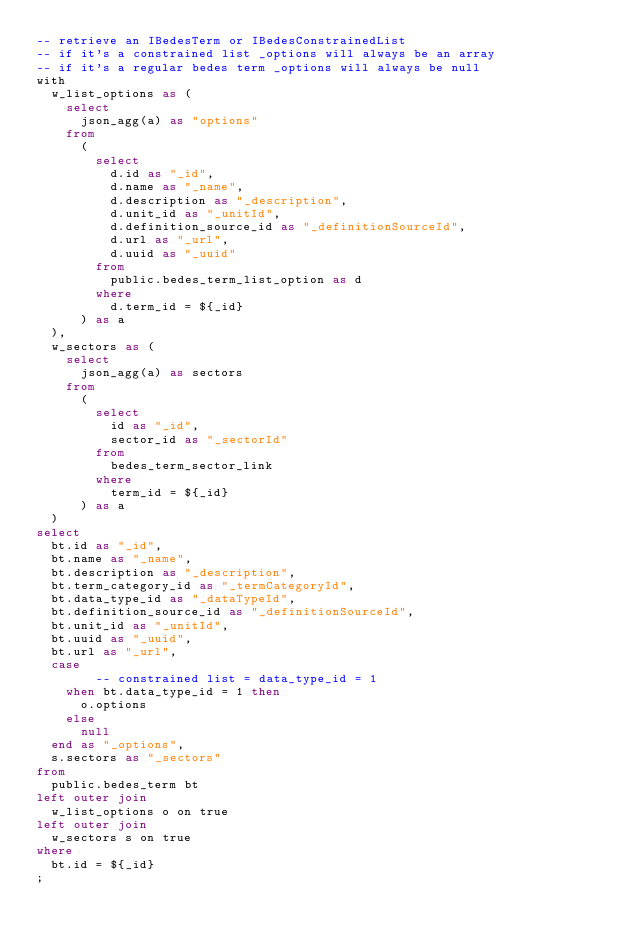Convert code to text. <code><loc_0><loc_0><loc_500><loc_500><_SQL_>-- retrieve an IBedesTerm or IBedesConstrainedList
-- if it's a constrained list _options will always be an array
-- if it's a regular bedes term _options will always be null
with
	w_list_options as (
		select
			json_agg(a) as "options"
		from
			(
				select
					d.id as "_id",
					d.name as "_name",
					d.description as "_description",
					d.unit_id as "_unitId",
					d.definition_source_id as "_definitionSourceId",
					d.url as "_url",
					d.uuid as "_uuid"
				from
					public.bedes_term_list_option as d
				where
					d.term_id = ${_id}
			) as a
	),
	w_sectors as (
		select
			json_agg(a) as sectors
		from
			(
				select
					id as "_id",
					sector_id as "_sectorId"
				from
					bedes_term_sector_link
				where
					term_id = ${_id}
			) as a
	)
select
	bt.id as "_id",
	bt.name as "_name",
	bt.description as "_description",
	bt.term_category_id as "_termCategoryId",
	bt.data_type_id as "_dataTypeId",
	bt.definition_source_id as "_definitionSourceId",
	bt.unit_id as "_unitId",
	bt.uuid as "_uuid",
	bt.url as "_url",
	case
        -- constrained list = data_type_id = 1
		when bt.data_type_id = 1 then
			o.options
		else
			null
	end as "_options",
	s.sectors as "_sectors"
from
	public.bedes_term bt
left outer join 
	w_list_options o on true
left outer join
	w_sectors s on true
where
	bt.id = ${_id}
;</code> 